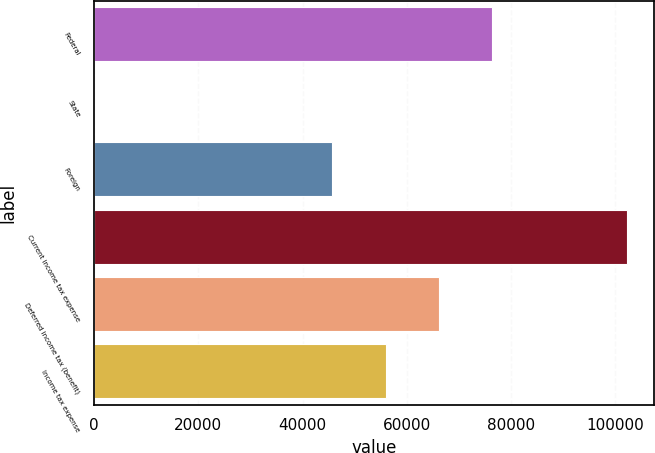<chart> <loc_0><loc_0><loc_500><loc_500><bar_chart><fcel>Federal<fcel>State<fcel>Foreign<fcel>Current income tax expense<fcel>Deferred income tax (benefit)<fcel>Income tax expense<nl><fcel>76373.2<fcel>24<fcel>45721<fcel>102198<fcel>66155.8<fcel>55938.4<nl></chart> 